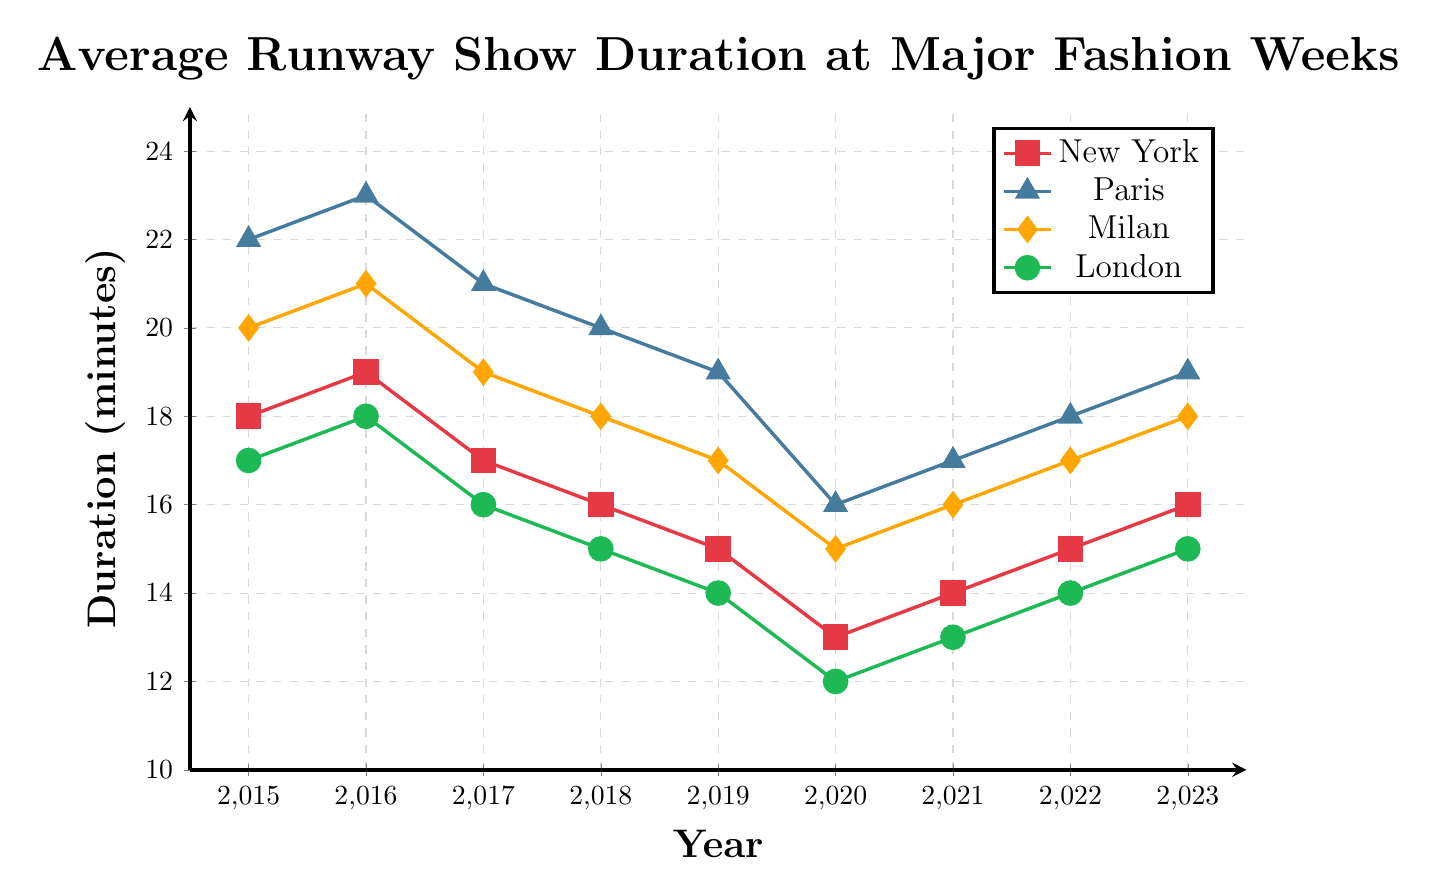What year had the shortest average runway show duration for Milan Fashion Week? To find the shortest average runway show duration for Milan Fashion Week, observe the yellow diamond markers on the graph. The shortest duration is in 2020 with 15 minutes.
Answer: 2020 Which fashion week had the longest average show duration in 2018, and what was the duration? To determine the longest average show duration in 2018, compare the heights of all points for that year. Paris Fashion Week (blue triangle) had the longest average show duration, with 20 minutes.
Answer: Paris, 20 minutes By how many minutes did the average duration of New York Fashion Week shows change from 2015 to 2020? In 2015, New York Fashion Week's (red square) average duration was 18 minutes. In 2020, it was 13 minutes. Subtract 13 from 18 to get the change, which is 5 minutes.
Answer: 5 minutes Which year showed the most significant drop in the average duration for Paris Fashion Week compared to the previous year? Compare the duration of Paris Fashion Week (blue triangle) each year. There is a 3-minute drop from 2019 to 2020 (19 to 16 minutes). This is the most significant drop.
Answer: 2019 to 2020 Between New York and Milan Fashion Weeks, which had a greater increase in average show duration from 2020 to 2023, and by how much? For New York Fashion Week (red square), the duration increased from 13 minutes in 2020 to 16 minutes in 2023, a 3-minute increase. For Milan Fashion Week (yellow diamond), it increased from 15 to 18 minutes, also a 3-minute increase.
Answer: Both increased by 3 minutes How did the average duration of shows at London Fashion Week change from 2015 to 2023? To determine the change, look at the green circle markers for London Fashion Week. The duration decreased from 17 minutes in 2015 to 15 minutes in 2023. The change is a decrease of 2 minutes.
Answer: Decreased by 2 minutes In which year did all fashion weeks have the lowest average show duration simultaneously, and what were the durations? The year with the lowest simultaneous durations can be determined by observing the lowest points of all lines together. In 2020, New York had 13 minutes, Paris 16 minutes, Milan 15 minutes, and London 12 minutes.
Answer: 2020: New York 13, Paris 16, Milan 15, London 12 Among all fashion weeks, which one had the steadiest decline in average show duration from 2015 to 2020? Evaluate the stability of decline by observing the trendlines. Milan Fashion Week (yellow diamond) shows a steady, almost linear decline in duration from 20 to 15 minutes.
Answer: Milan Fashion Week 